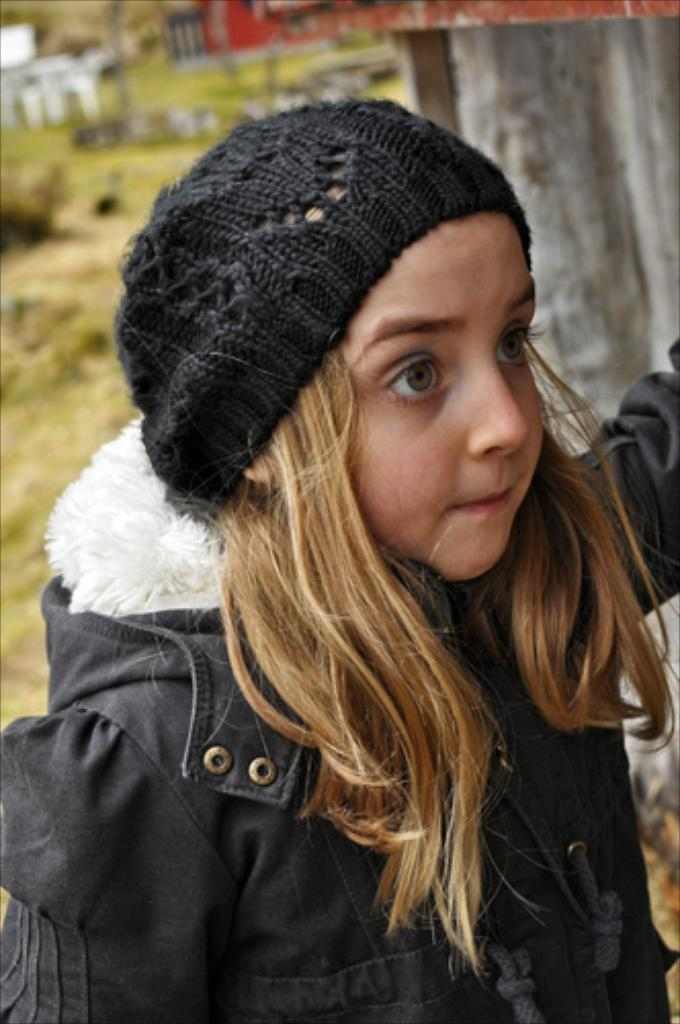Who is the main subject in the image? There is a girl in the image. What is the girl wearing on her upper body? The girl is wearing a coat. What is the girl wearing on her head? The girl is wearing a cap. How many pizzas can be seen in the image? There are no pizzas present in the image. What shape is the beggar in the image? There is no beggar present in the image. 